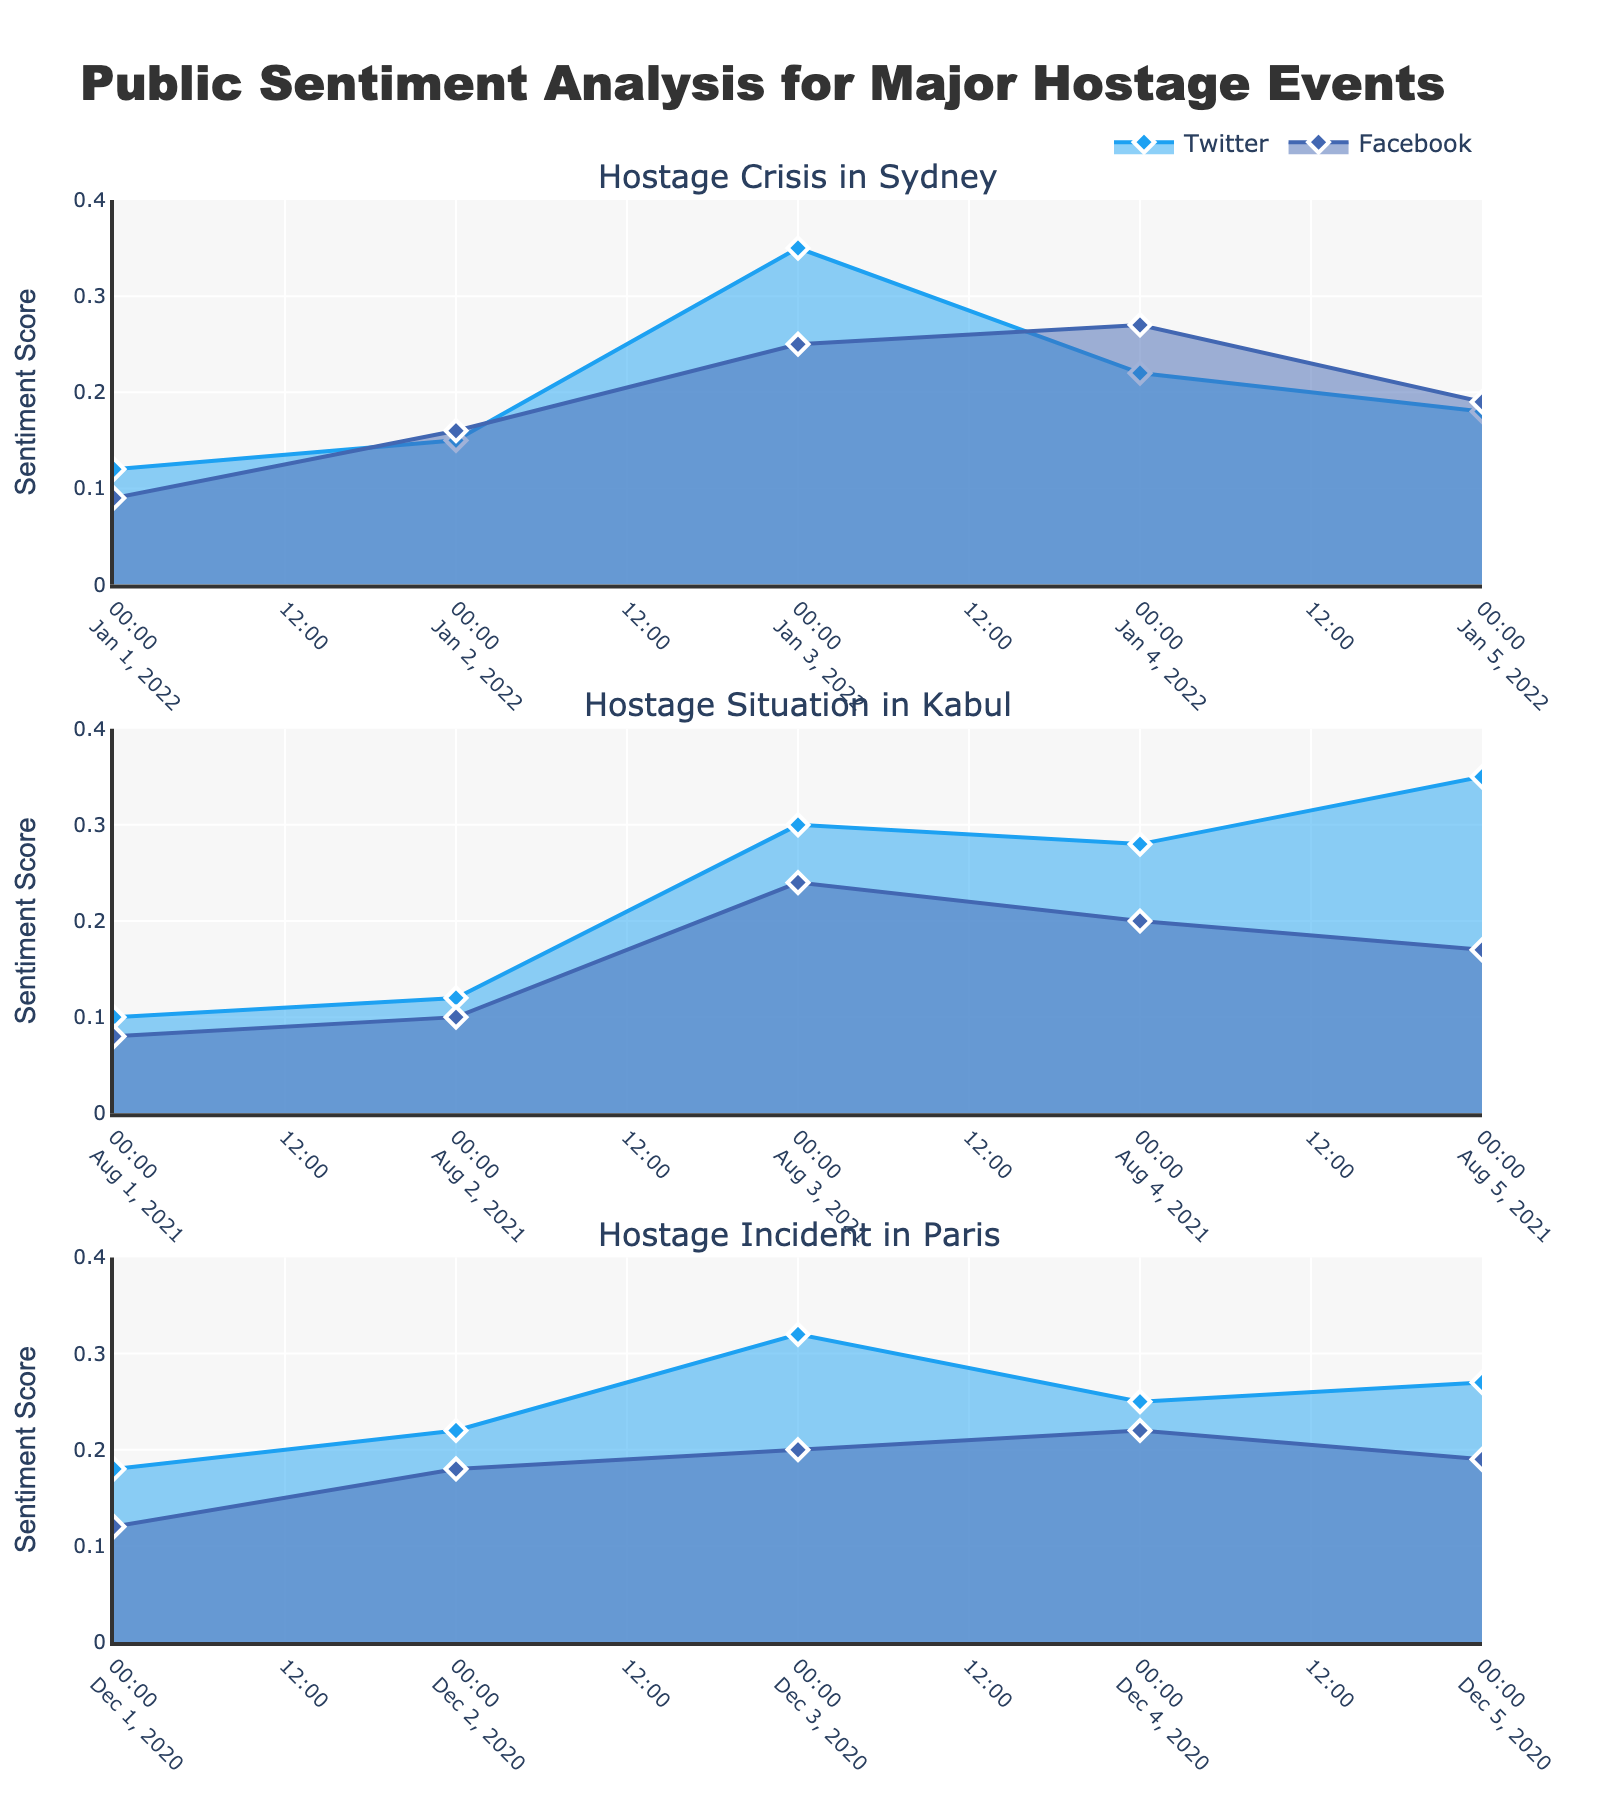What is the title of the figure? The title of the figure is generally located at the top of the chart and summarizes the content at a glance. In this case, it indicates the main subject of analysis.
Answer: "Public Sentiment Analysis for Major Hostage Events" Which platform shows a higher sentiment score for the "Hostage Crisis in Sydney" on January 03, 2022? To find this, look at the sentiment scores for both Twitter and Facebook on January 03, 2022, in the subplot labeled "Hostage Crisis in Sydney". Compare the heights (y-values) of the corresponding points on the line for each platform.
Answer: Twitter On which date did sentiment score peak for the "Hostage Situation in Kabul" on Facebook? Examine the subplot labeled "Hostage Situation in Kabul" and look for the highest point on the Facebook line. The date corresponding to this peak point is the answer.
Answer: August 03, 2021 What is the sentiment trend on Twitter for the "Hostage Incident in Paris" from December 01, 2020, to December 05, 2020? The trend can be observed by noting the overall direction of the Twitter line in the subplot labeled "Hostage Incident in Paris" over these dates. Identify if the line is generally increasing, decreasing, or stable.
Answer: Increasing Which hostage event shows the most significant sentiment fluctuation on Twitter? To determine the most significant fluctuation, compare the range of sentiment scores (difference between the highest and lowest values) for Twitter in each subplot. The event with the largest range indicates the most significant fluctuation.
Answer: Hostage Situation in Kabul What is the average sentiment score for Facebook across all events on the final recorded date? Identify the sentiment scores on Facebook for the last date in each subplot, add those values, then divide by the number of events.
Answer: (0.19 + 0.17 + 0.19) / 3 ≈ 0.18 How do the sentiment trends on Facebook compare between the "Hostage Crisis in Sydney" and the "Hostage Incident in Paris"? Compare the overall shape and direction of the Facebook lines in the subplots labeled "Hostage Crisis in Sydney" and "Hostage Incident in Paris". Note if they are both increasing, decreasing, or stable.
Answer: Both increasing Which platform generally has higher sentiment scores across the events? For each event, compare the sentiment scores of Twitter and Facebook. The platform that more frequently shows higher sentiment scores identifies the answer.
Answer: Twitter Is there a sentiment score crossover between platforms for any event? If so, when? Examine each subplot to see if and when the lines for Twitter and Facebook intersect, which indicates a crossover. Note the event and the date of crossover.
Answer: No 